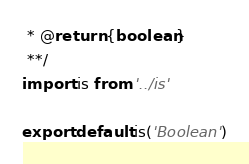Convert code to text. <code><loc_0><loc_0><loc_500><loc_500><_JavaScript_> * @return {boolean}
 **/
import is from '../is'

export default is('Boolean')
</code> 